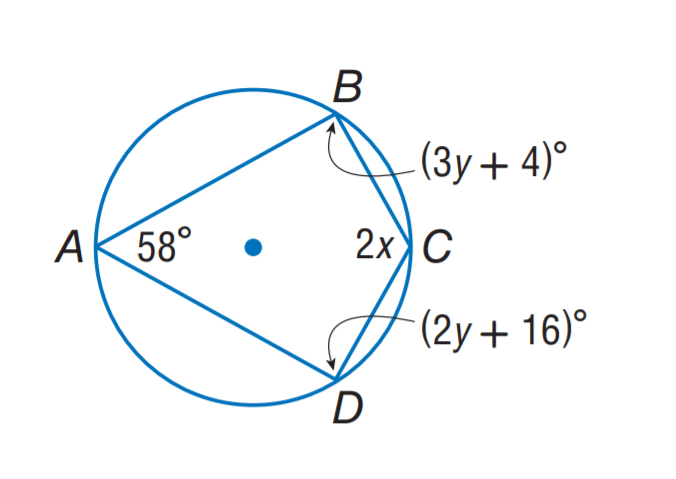Question: Find m \angle C.
Choices:
A. 80
B. 100
C. 112
D. 122
Answer with the letter. Answer: D 